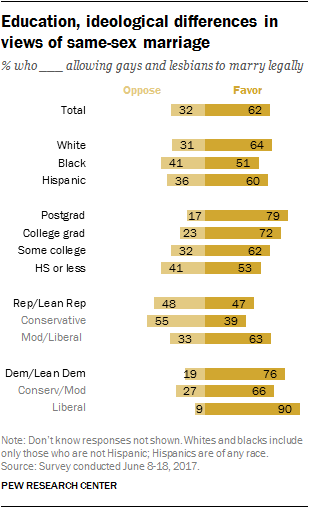Identify some key points in this picture. The liberal group has the largest difference between those who oppose an opinion and those who favor it. According to a recent survey, 31% of white people oppose allowing gays and lesbians to legally marry. 